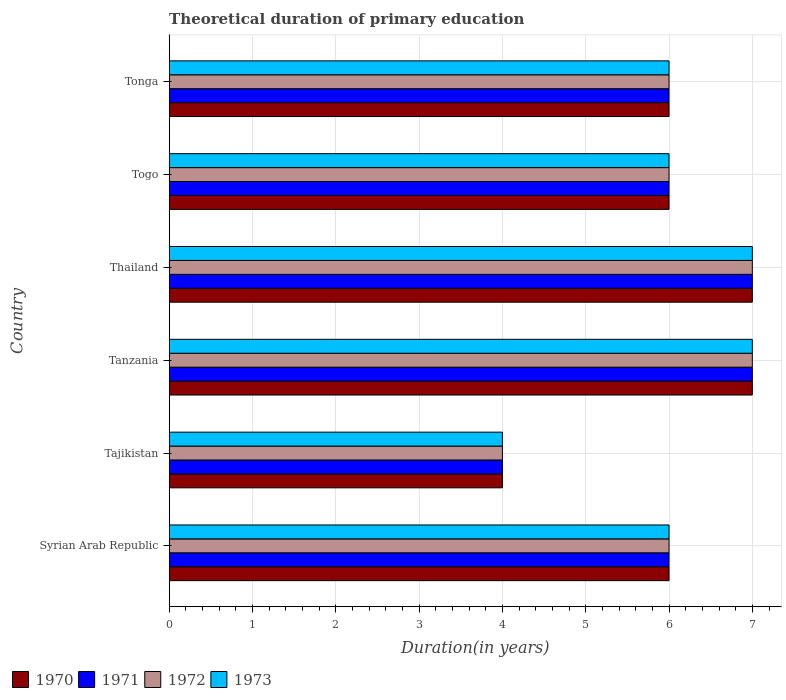How many different coloured bars are there?
Provide a short and direct response. 4. Are the number of bars per tick equal to the number of legend labels?
Keep it short and to the point. Yes. What is the label of the 3rd group of bars from the top?
Make the answer very short. Thailand. What is the total theoretical duration of primary education in 1972 in Tajikistan?
Give a very brief answer. 4. Across all countries, what is the maximum total theoretical duration of primary education in 1970?
Give a very brief answer. 7. In which country was the total theoretical duration of primary education in 1970 maximum?
Ensure brevity in your answer.  Tanzania. In which country was the total theoretical duration of primary education in 1971 minimum?
Provide a short and direct response. Tajikistan. What is the difference between the total theoretical duration of primary education in 1973 in Thailand and that in Tonga?
Offer a very short reply. 1. What is the difference between the total theoretical duration of primary education in 1970 in Tonga and the total theoretical duration of primary education in 1971 in Thailand?
Ensure brevity in your answer.  -1. What is the average total theoretical duration of primary education in 1971 per country?
Keep it short and to the point. 6. What is the ratio of the total theoretical duration of primary education in 1970 in Thailand to that in Tonga?
Make the answer very short. 1.17. Is the total theoretical duration of primary education in 1971 in Tanzania less than that in Thailand?
Your answer should be very brief. No. What is the difference between the highest and the second highest total theoretical duration of primary education in 1970?
Provide a short and direct response. 0. Is the sum of the total theoretical duration of primary education in 1973 in Thailand and Tonga greater than the maximum total theoretical duration of primary education in 1972 across all countries?
Give a very brief answer. Yes. Is it the case that in every country, the sum of the total theoretical duration of primary education in 1972 and total theoretical duration of primary education in 1970 is greater than the sum of total theoretical duration of primary education in 1971 and total theoretical duration of primary education in 1973?
Offer a terse response. No. What does the 1st bar from the top in Thailand represents?
Your answer should be very brief. 1973. How many bars are there?
Give a very brief answer. 24. Are all the bars in the graph horizontal?
Your answer should be compact. Yes. How many countries are there in the graph?
Make the answer very short. 6. Are the values on the major ticks of X-axis written in scientific E-notation?
Your response must be concise. No. Does the graph contain grids?
Provide a short and direct response. Yes. Where does the legend appear in the graph?
Provide a succinct answer. Bottom left. What is the title of the graph?
Offer a terse response. Theoretical duration of primary education. Does "1994" appear as one of the legend labels in the graph?
Your response must be concise. No. What is the label or title of the X-axis?
Provide a succinct answer. Duration(in years). What is the Duration(in years) of 1970 in Syrian Arab Republic?
Offer a very short reply. 6. What is the Duration(in years) of 1970 in Tajikistan?
Offer a very short reply. 4. What is the Duration(in years) of 1971 in Tajikistan?
Offer a terse response. 4. What is the Duration(in years) of 1972 in Tajikistan?
Ensure brevity in your answer.  4. What is the Duration(in years) of 1973 in Tajikistan?
Offer a very short reply. 4. What is the Duration(in years) in 1971 in Tanzania?
Provide a succinct answer. 7. What is the Duration(in years) in 1971 in Thailand?
Offer a very short reply. 7. What is the Duration(in years) in 1972 in Thailand?
Give a very brief answer. 7. What is the Duration(in years) in 1971 in Togo?
Ensure brevity in your answer.  6. What is the Duration(in years) of 1972 in Togo?
Your response must be concise. 6. What is the Duration(in years) of 1971 in Tonga?
Your answer should be compact. 6. What is the Duration(in years) of 1972 in Tonga?
Keep it short and to the point. 6. Across all countries, what is the maximum Duration(in years) in 1971?
Ensure brevity in your answer.  7. Across all countries, what is the maximum Duration(in years) of 1972?
Make the answer very short. 7. Across all countries, what is the minimum Duration(in years) in 1970?
Your answer should be compact. 4. Across all countries, what is the minimum Duration(in years) of 1971?
Offer a very short reply. 4. Across all countries, what is the minimum Duration(in years) of 1973?
Give a very brief answer. 4. What is the total Duration(in years) in 1972 in the graph?
Make the answer very short. 36. What is the difference between the Duration(in years) in 1970 in Syrian Arab Republic and that in Tajikistan?
Ensure brevity in your answer.  2. What is the difference between the Duration(in years) of 1971 in Syrian Arab Republic and that in Tajikistan?
Offer a terse response. 2. What is the difference between the Duration(in years) in 1972 in Syrian Arab Republic and that in Tajikistan?
Ensure brevity in your answer.  2. What is the difference between the Duration(in years) of 1970 in Syrian Arab Republic and that in Tanzania?
Provide a succinct answer. -1. What is the difference between the Duration(in years) in 1971 in Syrian Arab Republic and that in Tanzania?
Give a very brief answer. -1. What is the difference between the Duration(in years) of 1970 in Syrian Arab Republic and that in Thailand?
Keep it short and to the point. -1. What is the difference between the Duration(in years) of 1971 in Syrian Arab Republic and that in Thailand?
Your answer should be compact. -1. What is the difference between the Duration(in years) in 1972 in Syrian Arab Republic and that in Thailand?
Your response must be concise. -1. What is the difference between the Duration(in years) of 1971 in Syrian Arab Republic and that in Togo?
Make the answer very short. 0. What is the difference between the Duration(in years) of 1972 in Syrian Arab Republic and that in Togo?
Your answer should be compact. 0. What is the difference between the Duration(in years) in 1973 in Syrian Arab Republic and that in Togo?
Ensure brevity in your answer.  0. What is the difference between the Duration(in years) of 1973 in Syrian Arab Republic and that in Tonga?
Your response must be concise. 0. What is the difference between the Duration(in years) in 1973 in Tajikistan and that in Tanzania?
Your answer should be compact. -3. What is the difference between the Duration(in years) in 1971 in Tajikistan and that in Thailand?
Your answer should be very brief. -3. What is the difference between the Duration(in years) in 1970 in Tajikistan and that in Togo?
Your answer should be compact. -2. What is the difference between the Duration(in years) of 1972 in Tajikistan and that in Togo?
Give a very brief answer. -2. What is the difference between the Duration(in years) of 1973 in Tajikistan and that in Togo?
Your answer should be very brief. -2. What is the difference between the Duration(in years) in 1970 in Tajikistan and that in Tonga?
Your answer should be compact. -2. What is the difference between the Duration(in years) of 1971 in Tajikistan and that in Tonga?
Give a very brief answer. -2. What is the difference between the Duration(in years) of 1972 in Tajikistan and that in Tonga?
Offer a very short reply. -2. What is the difference between the Duration(in years) in 1970 in Tanzania and that in Thailand?
Offer a very short reply. 0. What is the difference between the Duration(in years) of 1971 in Tanzania and that in Thailand?
Your answer should be very brief. 0. What is the difference between the Duration(in years) in 1972 in Tanzania and that in Thailand?
Offer a terse response. 0. What is the difference between the Duration(in years) of 1970 in Tanzania and that in Togo?
Offer a very short reply. 1. What is the difference between the Duration(in years) in 1970 in Tanzania and that in Tonga?
Your answer should be very brief. 1. What is the difference between the Duration(in years) of 1971 in Tanzania and that in Tonga?
Provide a succinct answer. 1. What is the difference between the Duration(in years) in 1973 in Tanzania and that in Tonga?
Provide a short and direct response. 1. What is the difference between the Duration(in years) of 1972 in Thailand and that in Togo?
Provide a succinct answer. 1. What is the difference between the Duration(in years) in 1973 in Thailand and that in Togo?
Make the answer very short. 1. What is the difference between the Duration(in years) of 1971 in Thailand and that in Tonga?
Provide a succinct answer. 1. What is the difference between the Duration(in years) of 1972 in Thailand and that in Tonga?
Offer a very short reply. 1. What is the difference between the Duration(in years) in 1973 in Togo and that in Tonga?
Offer a terse response. 0. What is the difference between the Duration(in years) of 1970 in Syrian Arab Republic and the Duration(in years) of 1973 in Tajikistan?
Offer a terse response. 2. What is the difference between the Duration(in years) of 1970 in Syrian Arab Republic and the Duration(in years) of 1971 in Tanzania?
Offer a terse response. -1. What is the difference between the Duration(in years) of 1970 in Syrian Arab Republic and the Duration(in years) of 1972 in Tanzania?
Your response must be concise. -1. What is the difference between the Duration(in years) in 1970 in Syrian Arab Republic and the Duration(in years) in 1973 in Tanzania?
Ensure brevity in your answer.  -1. What is the difference between the Duration(in years) of 1972 in Syrian Arab Republic and the Duration(in years) of 1973 in Tanzania?
Ensure brevity in your answer.  -1. What is the difference between the Duration(in years) in 1970 in Syrian Arab Republic and the Duration(in years) in 1973 in Thailand?
Your answer should be compact. -1. What is the difference between the Duration(in years) of 1971 in Syrian Arab Republic and the Duration(in years) of 1972 in Thailand?
Provide a succinct answer. -1. What is the difference between the Duration(in years) of 1972 in Syrian Arab Republic and the Duration(in years) of 1973 in Thailand?
Offer a very short reply. -1. What is the difference between the Duration(in years) of 1970 in Syrian Arab Republic and the Duration(in years) of 1973 in Togo?
Offer a terse response. 0. What is the difference between the Duration(in years) of 1972 in Syrian Arab Republic and the Duration(in years) of 1973 in Togo?
Offer a very short reply. 0. What is the difference between the Duration(in years) of 1970 in Syrian Arab Republic and the Duration(in years) of 1973 in Tonga?
Your response must be concise. 0. What is the difference between the Duration(in years) of 1971 in Syrian Arab Republic and the Duration(in years) of 1973 in Tonga?
Your response must be concise. 0. What is the difference between the Duration(in years) of 1970 in Tajikistan and the Duration(in years) of 1972 in Thailand?
Provide a succinct answer. -3. What is the difference between the Duration(in years) in 1970 in Tajikistan and the Duration(in years) in 1973 in Thailand?
Your answer should be very brief. -3. What is the difference between the Duration(in years) of 1970 in Tajikistan and the Duration(in years) of 1971 in Togo?
Your answer should be very brief. -2. What is the difference between the Duration(in years) in 1970 in Tajikistan and the Duration(in years) in 1973 in Togo?
Ensure brevity in your answer.  -2. What is the difference between the Duration(in years) in 1971 in Tajikistan and the Duration(in years) in 1972 in Togo?
Your response must be concise. -2. What is the difference between the Duration(in years) of 1971 in Tajikistan and the Duration(in years) of 1973 in Togo?
Ensure brevity in your answer.  -2. What is the difference between the Duration(in years) of 1970 in Tajikistan and the Duration(in years) of 1971 in Tonga?
Make the answer very short. -2. What is the difference between the Duration(in years) in 1970 in Tajikistan and the Duration(in years) in 1972 in Tonga?
Provide a succinct answer. -2. What is the difference between the Duration(in years) in 1970 in Tajikistan and the Duration(in years) in 1973 in Tonga?
Ensure brevity in your answer.  -2. What is the difference between the Duration(in years) of 1971 in Tajikistan and the Duration(in years) of 1973 in Tonga?
Your response must be concise. -2. What is the difference between the Duration(in years) of 1972 in Tajikistan and the Duration(in years) of 1973 in Tonga?
Your answer should be very brief. -2. What is the difference between the Duration(in years) in 1970 in Tanzania and the Duration(in years) in 1971 in Thailand?
Provide a succinct answer. 0. What is the difference between the Duration(in years) of 1970 in Tanzania and the Duration(in years) of 1972 in Thailand?
Provide a succinct answer. 0. What is the difference between the Duration(in years) of 1971 in Tanzania and the Duration(in years) of 1972 in Thailand?
Offer a terse response. 0. What is the difference between the Duration(in years) of 1972 in Tanzania and the Duration(in years) of 1973 in Thailand?
Offer a very short reply. 0. What is the difference between the Duration(in years) of 1970 in Tanzania and the Duration(in years) of 1973 in Togo?
Your response must be concise. 1. What is the difference between the Duration(in years) in 1970 in Tanzania and the Duration(in years) in 1971 in Tonga?
Offer a terse response. 1. What is the difference between the Duration(in years) in 1971 in Tanzania and the Duration(in years) in 1972 in Tonga?
Offer a terse response. 1. What is the difference between the Duration(in years) in 1971 in Tanzania and the Duration(in years) in 1973 in Tonga?
Offer a terse response. 1. What is the difference between the Duration(in years) of 1972 in Tanzania and the Duration(in years) of 1973 in Tonga?
Your answer should be compact. 1. What is the difference between the Duration(in years) of 1970 in Thailand and the Duration(in years) of 1972 in Togo?
Ensure brevity in your answer.  1. What is the difference between the Duration(in years) of 1971 in Thailand and the Duration(in years) of 1973 in Togo?
Offer a terse response. 1. What is the difference between the Duration(in years) of 1970 in Thailand and the Duration(in years) of 1972 in Tonga?
Your answer should be very brief. 1. What is the difference between the Duration(in years) in 1970 in Thailand and the Duration(in years) in 1973 in Tonga?
Provide a short and direct response. 1. What is the difference between the Duration(in years) of 1971 in Thailand and the Duration(in years) of 1972 in Tonga?
Ensure brevity in your answer.  1. What is the difference between the Duration(in years) of 1972 in Thailand and the Duration(in years) of 1973 in Tonga?
Give a very brief answer. 1. What is the difference between the Duration(in years) of 1970 in Togo and the Duration(in years) of 1971 in Tonga?
Offer a very short reply. 0. What is the difference between the Duration(in years) in 1971 in Togo and the Duration(in years) in 1973 in Tonga?
Provide a succinct answer. 0. What is the difference between the Duration(in years) in 1972 in Togo and the Duration(in years) in 1973 in Tonga?
Your answer should be very brief. 0. What is the average Duration(in years) of 1971 per country?
Provide a succinct answer. 6. What is the average Duration(in years) of 1972 per country?
Your response must be concise. 6. What is the difference between the Duration(in years) of 1970 and Duration(in years) of 1973 in Syrian Arab Republic?
Offer a terse response. 0. What is the difference between the Duration(in years) of 1972 and Duration(in years) of 1973 in Syrian Arab Republic?
Your answer should be compact. 0. What is the difference between the Duration(in years) of 1970 and Duration(in years) of 1971 in Tajikistan?
Offer a very short reply. 0. What is the difference between the Duration(in years) in 1970 and Duration(in years) in 1972 in Tajikistan?
Provide a short and direct response. 0. What is the difference between the Duration(in years) in 1972 and Duration(in years) in 1973 in Tajikistan?
Provide a succinct answer. 0. What is the difference between the Duration(in years) in 1971 and Duration(in years) in 1972 in Tanzania?
Provide a succinct answer. 0. What is the difference between the Duration(in years) of 1971 and Duration(in years) of 1973 in Tanzania?
Your answer should be very brief. 0. What is the difference between the Duration(in years) of 1972 and Duration(in years) of 1973 in Tanzania?
Your answer should be very brief. 0. What is the difference between the Duration(in years) in 1970 and Duration(in years) in 1973 in Thailand?
Your answer should be compact. 0. What is the difference between the Duration(in years) in 1971 and Duration(in years) in 1972 in Thailand?
Give a very brief answer. 0. What is the difference between the Duration(in years) in 1971 and Duration(in years) in 1973 in Thailand?
Provide a short and direct response. 0. What is the difference between the Duration(in years) of 1971 and Duration(in years) of 1972 in Togo?
Ensure brevity in your answer.  0. What is the difference between the Duration(in years) in 1972 and Duration(in years) in 1973 in Togo?
Your response must be concise. 0. What is the difference between the Duration(in years) in 1970 and Duration(in years) in 1972 in Tonga?
Offer a terse response. 0. What is the ratio of the Duration(in years) in 1972 in Syrian Arab Republic to that in Tajikistan?
Your answer should be very brief. 1.5. What is the ratio of the Duration(in years) in 1970 in Syrian Arab Republic to that in Tanzania?
Keep it short and to the point. 0.86. What is the ratio of the Duration(in years) in 1972 in Syrian Arab Republic to that in Tanzania?
Ensure brevity in your answer.  0.86. What is the ratio of the Duration(in years) in 1973 in Syrian Arab Republic to that in Tanzania?
Provide a succinct answer. 0.86. What is the ratio of the Duration(in years) in 1972 in Syrian Arab Republic to that in Thailand?
Your response must be concise. 0.86. What is the ratio of the Duration(in years) of 1971 in Syrian Arab Republic to that in Togo?
Offer a very short reply. 1. What is the ratio of the Duration(in years) of 1972 in Syrian Arab Republic to that in Togo?
Offer a terse response. 1. What is the ratio of the Duration(in years) in 1973 in Syrian Arab Republic to that in Togo?
Your response must be concise. 1. What is the ratio of the Duration(in years) of 1970 in Syrian Arab Republic to that in Tonga?
Give a very brief answer. 1. What is the ratio of the Duration(in years) of 1971 in Syrian Arab Republic to that in Tonga?
Provide a short and direct response. 1. What is the ratio of the Duration(in years) of 1973 in Syrian Arab Republic to that in Tonga?
Ensure brevity in your answer.  1. What is the ratio of the Duration(in years) in 1970 in Tajikistan to that in Tanzania?
Offer a terse response. 0.57. What is the ratio of the Duration(in years) of 1971 in Tajikistan to that in Tanzania?
Ensure brevity in your answer.  0.57. What is the ratio of the Duration(in years) in 1972 in Tajikistan to that in Thailand?
Make the answer very short. 0.57. What is the ratio of the Duration(in years) in 1971 in Tajikistan to that in Togo?
Offer a very short reply. 0.67. What is the ratio of the Duration(in years) in 1970 in Tajikistan to that in Tonga?
Provide a succinct answer. 0.67. What is the ratio of the Duration(in years) of 1972 in Tajikistan to that in Tonga?
Your answer should be very brief. 0.67. What is the ratio of the Duration(in years) of 1973 in Tajikistan to that in Tonga?
Give a very brief answer. 0.67. What is the ratio of the Duration(in years) of 1971 in Tanzania to that in Thailand?
Keep it short and to the point. 1. What is the ratio of the Duration(in years) of 1972 in Tanzania to that in Thailand?
Ensure brevity in your answer.  1. What is the ratio of the Duration(in years) of 1973 in Tanzania to that in Thailand?
Ensure brevity in your answer.  1. What is the ratio of the Duration(in years) in 1973 in Tanzania to that in Togo?
Provide a short and direct response. 1.17. What is the ratio of the Duration(in years) in 1970 in Tanzania to that in Tonga?
Keep it short and to the point. 1.17. What is the ratio of the Duration(in years) in 1971 in Tanzania to that in Tonga?
Ensure brevity in your answer.  1.17. What is the ratio of the Duration(in years) of 1973 in Tanzania to that in Tonga?
Your response must be concise. 1.17. What is the ratio of the Duration(in years) of 1972 in Thailand to that in Togo?
Give a very brief answer. 1.17. What is the ratio of the Duration(in years) in 1973 in Thailand to that in Togo?
Your answer should be compact. 1.17. What is the ratio of the Duration(in years) of 1970 in Thailand to that in Tonga?
Provide a succinct answer. 1.17. What is the ratio of the Duration(in years) in 1971 in Thailand to that in Tonga?
Your answer should be very brief. 1.17. What is the ratio of the Duration(in years) of 1972 in Thailand to that in Tonga?
Provide a short and direct response. 1.17. What is the ratio of the Duration(in years) in 1970 in Togo to that in Tonga?
Keep it short and to the point. 1. What is the ratio of the Duration(in years) of 1971 in Togo to that in Tonga?
Ensure brevity in your answer.  1. What is the difference between the highest and the second highest Duration(in years) of 1970?
Ensure brevity in your answer.  0. What is the difference between the highest and the second highest Duration(in years) of 1972?
Provide a short and direct response. 0. 